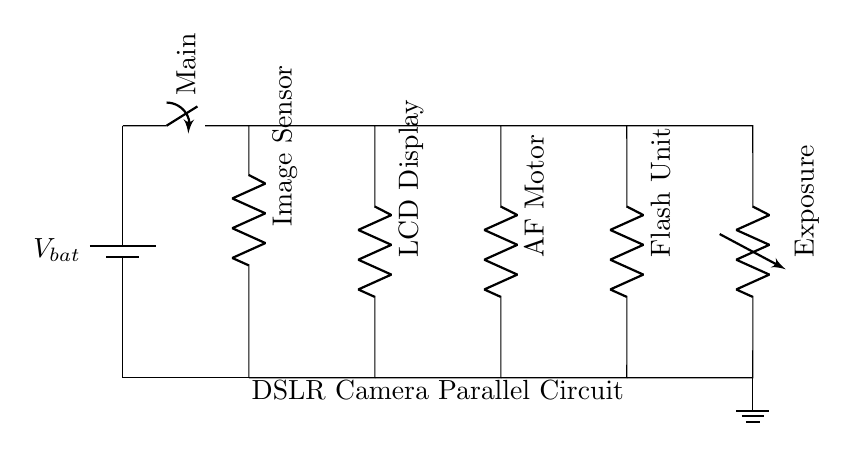What is the name of the power source in this circuit? The power source in the circuit is labeled as 'V bat', which indicates it is a battery supplying voltage.
Answer: V bat How many branches are in this parallel circuit? By counting the lines connecting to each component from the main switch, there are five distinct branches in the circuit.
Answer: Five What component is used to control exposure in this circuit? The variable resistor is labeled as 'Exposure' and is controlling the adjustment related to exposure in the circuit.
Answer: Exposure Which component directly powers the LCD display? The branch leading to the LCD display directly connects from the main switch and is specifically labeled as 'LCD Display'.
Answer: LCD Display What type of circuit is this configuration? Since the components provide multiple paths for current to flow, this configuration is classified as a parallel circuit.
Answer: Parallel Which component shares a branch with the image sensor? The image sensor is connected in its own branch, and the only component that shares a branch with it is the ground connection at the bottom of the circuit.
Answer: Ground 